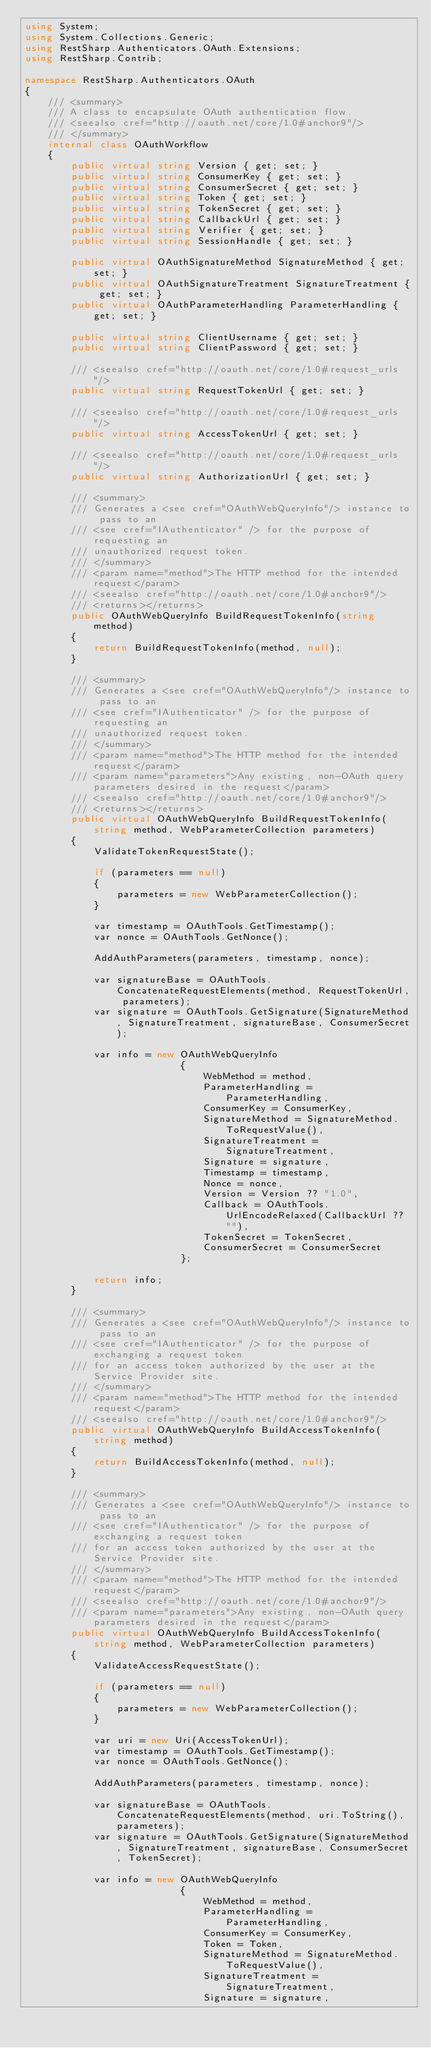<code> <loc_0><loc_0><loc_500><loc_500><_C#_>using System;
using System.Collections.Generic;
using RestSharp.Authenticators.OAuth.Extensions;
using RestSharp.Contrib;

namespace RestSharp.Authenticators.OAuth
{
    /// <summary>
    /// A class to encapsulate OAuth authentication flow.
    /// <seealso cref="http://oauth.net/core/1.0#anchor9"/>
    /// </summary>
    internal class OAuthWorkflow
    {
        public virtual string Version { get; set; }
        public virtual string ConsumerKey { get; set; }
        public virtual string ConsumerSecret { get; set; }
        public virtual string Token { get; set; }
        public virtual string TokenSecret { get; set; }
        public virtual string CallbackUrl { get; set; }
        public virtual string Verifier { get; set; }
        public virtual string SessionHandle { get; set; }
        
        public virtual OAuthSignatureMethod SignatureMethod { get; set; }
        public virtual OAuthSignatureTreatment SignatureTreatment { get; set; }
        public virtual OAuthParameterHandling ParameterHandling { get; set; }

        public virtual string ClientUsername { get; set; }
        public virtual string ClientPassword { get; set; }

        /// <seealso cref="http://oauth.net/core/1.0#request_urls"/>
        public virtual string RequestTokenUrl { get; set; }

        /// <seealso cref="http://oauth.net/core/1.0#request_urls"/>
        public virtual string AccessTokenUrl { get; set; }

        /// <seealso cref="http://oauth.net/core/1.0#request_urls"/>
        public virtual string AuthorizationUrl { get; set; }

        /// <summary>
        /// Generates a <see cref="OAuthWebQueryInfo"/> instance to pass to an
        /// <see cref="IAuthenticator" /> for the purpose of requesting an
        /// unauthorized request token.
        /// </summary>
        /// <param name="method">The HTTP method for the intended request</param>
        /// <seealso cref="http://oauth.net/core/1.0#anchor9"/>
        /// <returns></returns>
        public OAuthWebQueryInfo BuildRequestTokenInfo(string method)
        {
            return BuildRequestTokenInfo(method, null);
        }
        
        /// <summary>
        /// Generates a <see cref="OAuthWebQueryInfo"/> instance to pass to an
        /// <see cref="IAuthenticator" /> for the purpose of requesting an
        /// unauthorized request token.
        /// </summary>
        /// <param name="method">The HTTP method for the intended request</param>
        /// <param name="parameters">Any existing, non-OAuth query parameters desired in the request</param>
        /// <seealso cref="http://oauth.net/core/1.0#anchor9"/>
        /// <returns></returns>
        public virtual OAuthWebQueryInfo BuildRequestTokenInfo(string method, WebParameterCollection parameters)
        {
            ValidateTokenRequestState();

            if (parameters == null)
            {
                parameters = new WebParameterCollection();
            }

            var timestamp = OAuthTools.GetTimestamp();
            var nonce = OAuthTools.GetNonce();

            AddAuthParameters(parameters, timestamp, nonce);

            var signatureBase = OAuthTools.ConcatenateRequestElements(method, RequestTokenUrl, parameters);
            var signature = OAuthTools.GetSignature(SignatureMethod, SignatureTreatment, signatureBase, ConsumerSecret);

            var info = new OAuthWebQueryInfo
                           {
                               WebMethod = method,
                               ParameterHandling = ParameterHandling,
                               ConsumerKey = ConsumerKey,
                               SignatureMethod = SignatureMethod.ToRequestValue(),
                               SignatureTreatment = SignatureTreatment,
                               Signature = signature,
                               Timestamp = timestamp,
                               Nonce = nonce,
                               Version = Version ?? "1.0",
                               Callback = OAuthTools.UrlEncodeRelaxed(CallbackUrl ?? ""),
                               TokenSecret = TokenSecret,
                               ConsumerSecret = ConsumerSecret
                           };

            return info;
        }

        /// <summary>
        /// Generates a <see cref="OAuthWebQueryInfo"/> instance to pass to an
        /// <see cref="IAuthenticator" /> for the purpose of exchanging a request token
        /// for an access token authorized by the user at the Service Provider site.
        /// </summary>
        /// <param name="method">The HTTP method for the intended request</param>
        /// <seealso cref="http://oauth.net/core/1.0#anchor9"/>
        public virtual OAuthWebQueryInfo BuildAccessTokenInfo(string method)
        {
            return BuildAccessTokenInfo(method, null);
        }

        /// <summary>
        /// Generates a <see cref="OAuthWebQueryInfo"/> instance to pass to an
        /// <see cref="IAuthenticator" /> for the purpose of exchanging a request token
        /// for an access token authorized by the user at the Service Provider site.
        /// </summary>
        /// <param name="method">The HTTP method for the intended request</param>
        /// <seealso cref="http://oauth.net/core/1.0#anchor9"/>
        /// <param name="parameters">Any existing, non-OAuth query parameters desired in the request</param>
        public virtual OAuthWebQueryInfo BuildAccessTokenInfo(string method, WebParameterCollection parameters)
        {
            ValidateAccessRequestState();

            if (parameters == null)
            {
                parameters = new WebParameterCollection();
            }

            var uri = new Uri(AccessTokenUrl);
            var timestamp = OAuthTools.GetTimestamp();
            var nonce = OAuthTools.GetNonce();

            AddAuthParameters(parameters, timestamp, nonce);

            var signatureBase = OAuthTools.ConcatenateRequestElements(method, uri.ToString(), parameters);
            var signature = OAuthTools.GetSignature(SignatureMethod, SignatureTreatment, signatureBase, ConsumerSecret, TokenSecret);

            var info = new OAuthWebQueryInfo
                           {
                               WebMethod = method,
                               ParameterHandling = ParameterHandling,
                               ConsumerKey = ConsumerKey,
                               Token = Token,
                               SignatureMethod = SignatureMethod.ToRequestValue(),
                               SignatureTreatment = SignatureTreatment,
                               Signature = signature,</code> 